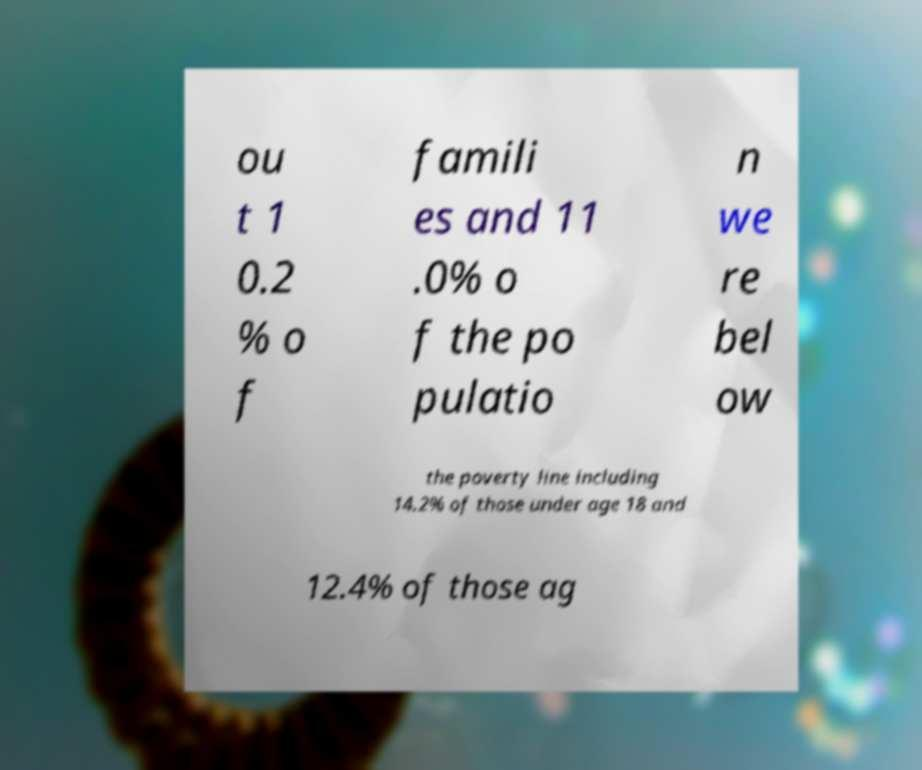I need the written content from this picture converted into text. Can you do that? ou t 1 0.2 % o f famili es and 11 .0% o f the po pulatio n we re bel ow the poverty line including 14.2% of those under age 18 and 12.4% of those ag 